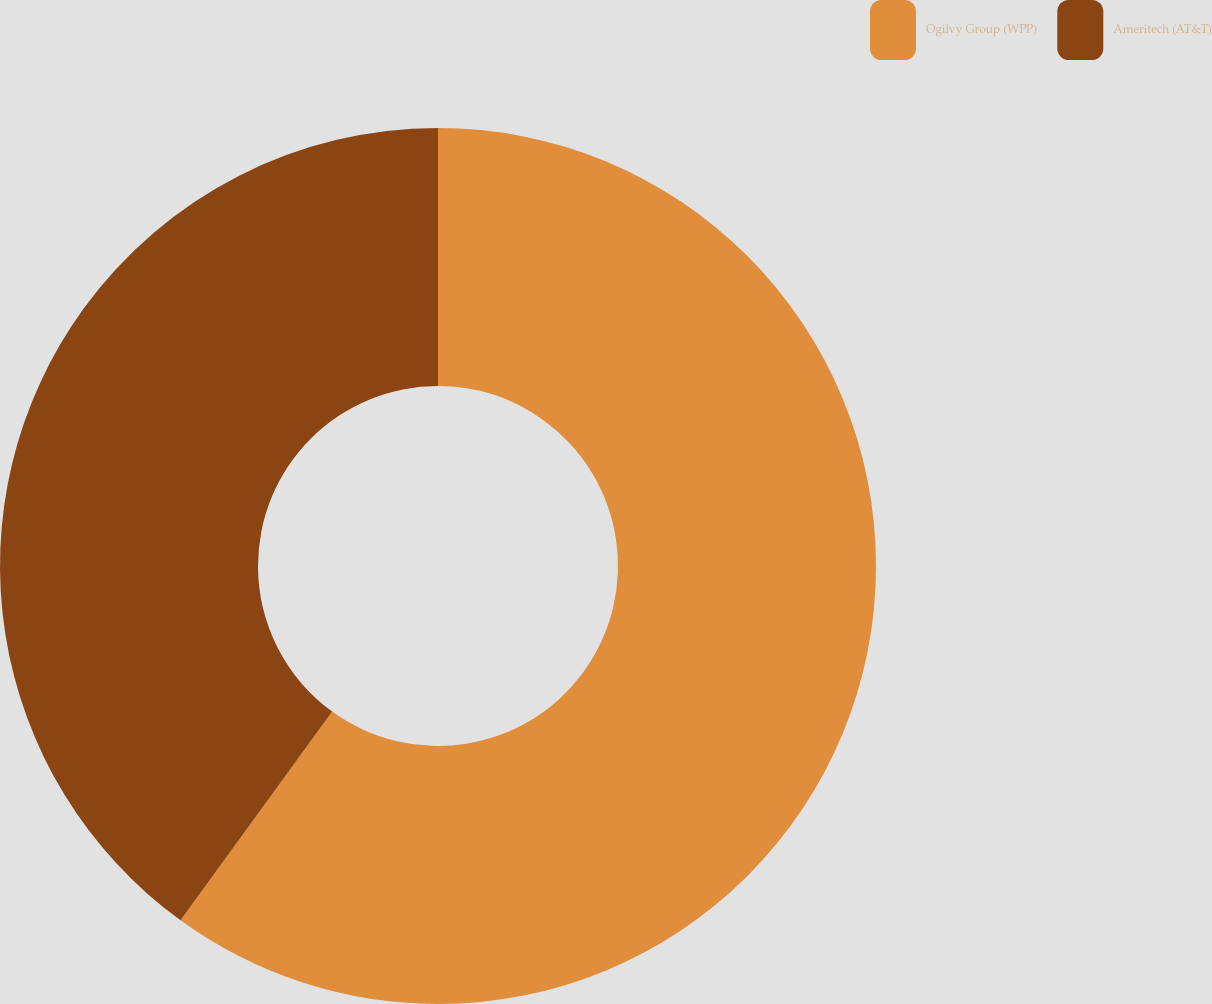<chart> <loc_0><loc_0><loc_500><loc_500><pie_chart><fcel>Ogilvy Group (WPP)<fcel>Ameritech (AT&T)<nl><fcel>60.0%<fcel>40.0%<nl></chart> 